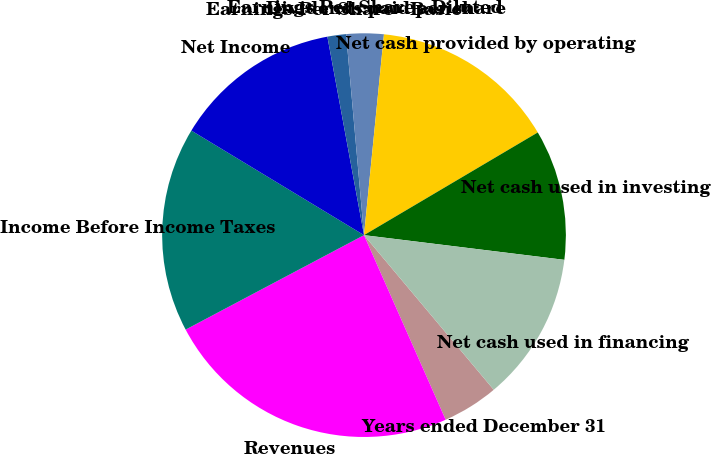Convert chart. <chart><loc_0><loc_0><loc_500><loc_500><pie_chart><fcel>Years ended December 31<fcel>Revenues<fcel>Income Before Income Taxes<fcel>Net Income<fcel>Earnings Per Share - Basic<fcel>Earnings Per Share - Diluted<fcel>Dividends paid per share<fcel>Net cash provided by operating<fcel>Net cash used in investing<fcel>Net cash used in financing<nl><fcel>4.48%<fcel>23.88%<fcel>16.42%<fcel>13.43%<fcel>1.49%<fcel>2.99%<fcel>0.0%<fcel>14.93%<fcel>10.45%<fcel>11.94%<nl></chart> 